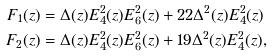Convert formula to latex. <formula><loc_0><loc_0><loc_500><loc_500>F _ { 1 } ( z ) & = \Delta ( z ) E _ { 4 } ^ { 2 } ( z ) E _ { 6 } ^ { 2 } ( z ) + 2 2 \Delta ^ { 2 } ( z ) E _ { 4 } ^ { 2 } ( z ) \\ F _ { 2 } ( z ) & = \Delta ( z ) E _ { 4 } ^ { 2 } ( z ) E _ { 6 } ^ { 2 } ( z ) + 1 9 \Delta ^ { 2 } ( z ) E _ { 4 } ^ { 2 } ( z ) ,</formula> 